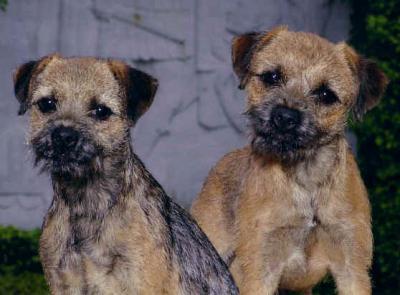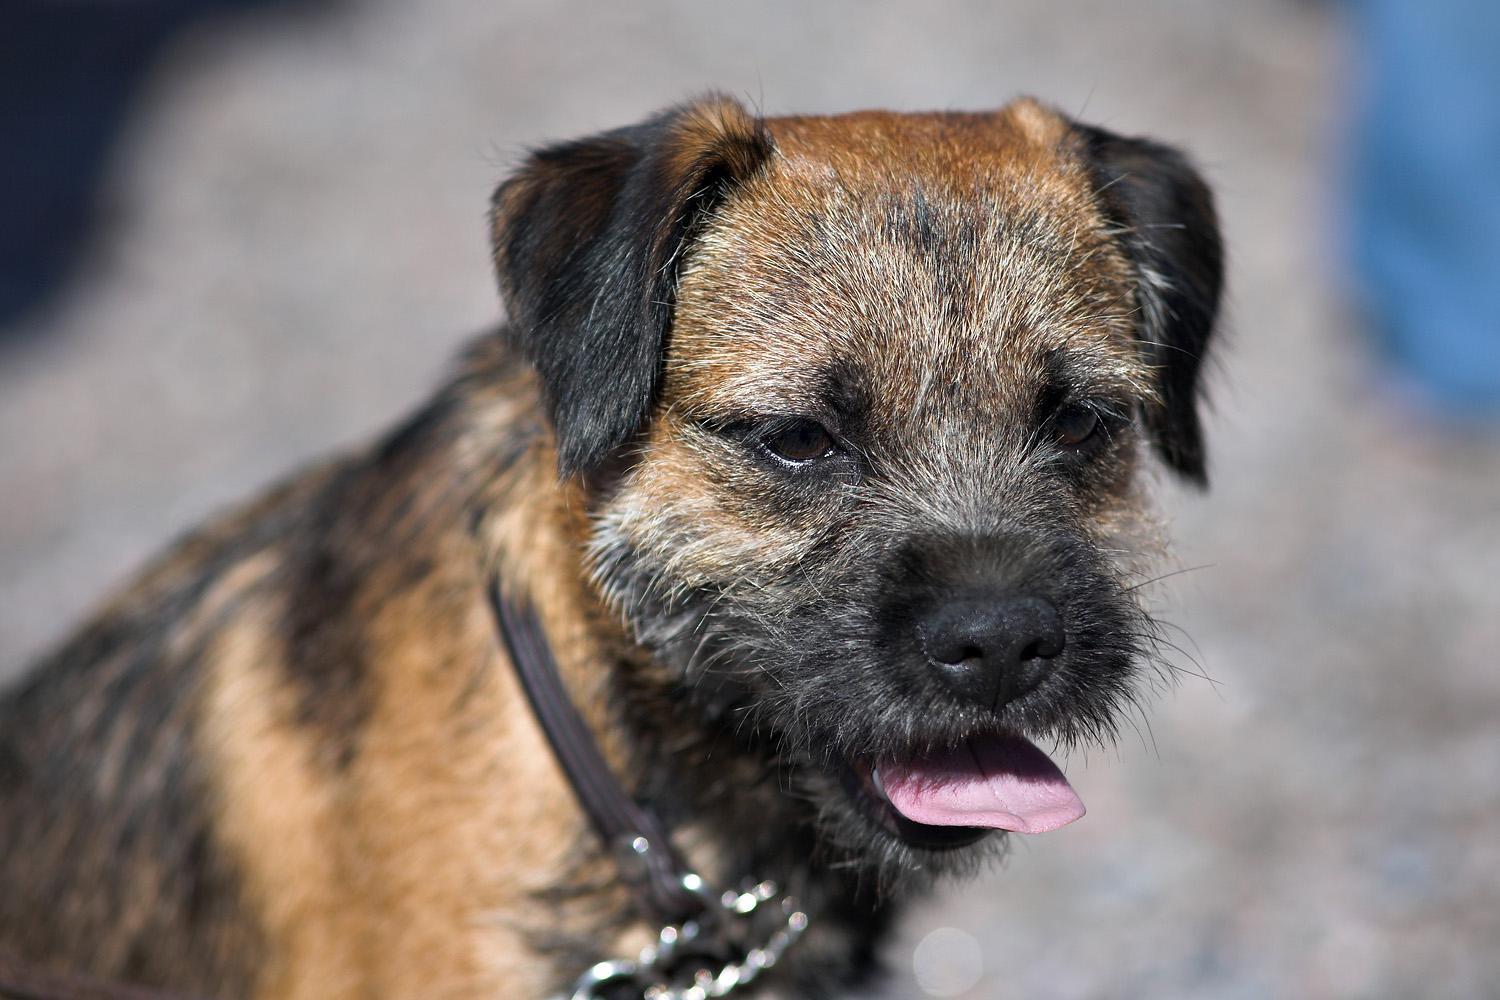The first image is the image on the left, the second image is the image on the right. Given the left and right images, does the statement "brightly colored collars are visible" hold true? Answer yes or no. No. The first image is the image on the left, the second image is the image on the right. For the images shown, is this caption "One dog is wearing a collar with a round tag clearly visible." true? Answer yes or no. No. The first image is the image on the left, the second image is the image on the right. For the images shown, is this caption "There are two dogs, and one of them is lying down." true? Answer yes or no. No. 